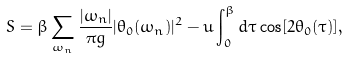<formula> <loc_0><loc_0><loc_500><loc_500>S = \beta \sum _ { \omega _ { n } } \frac { | \omega _ { n } | } { \pi g } | \theta _ { 0 } ( \omega _ { n } ) | ^ { 2 } - u \int _ { 0 } ^ { \beta } d \tau \cos [ 2 \theta _ { 0 } ( \tau ) ] ,</formula> 